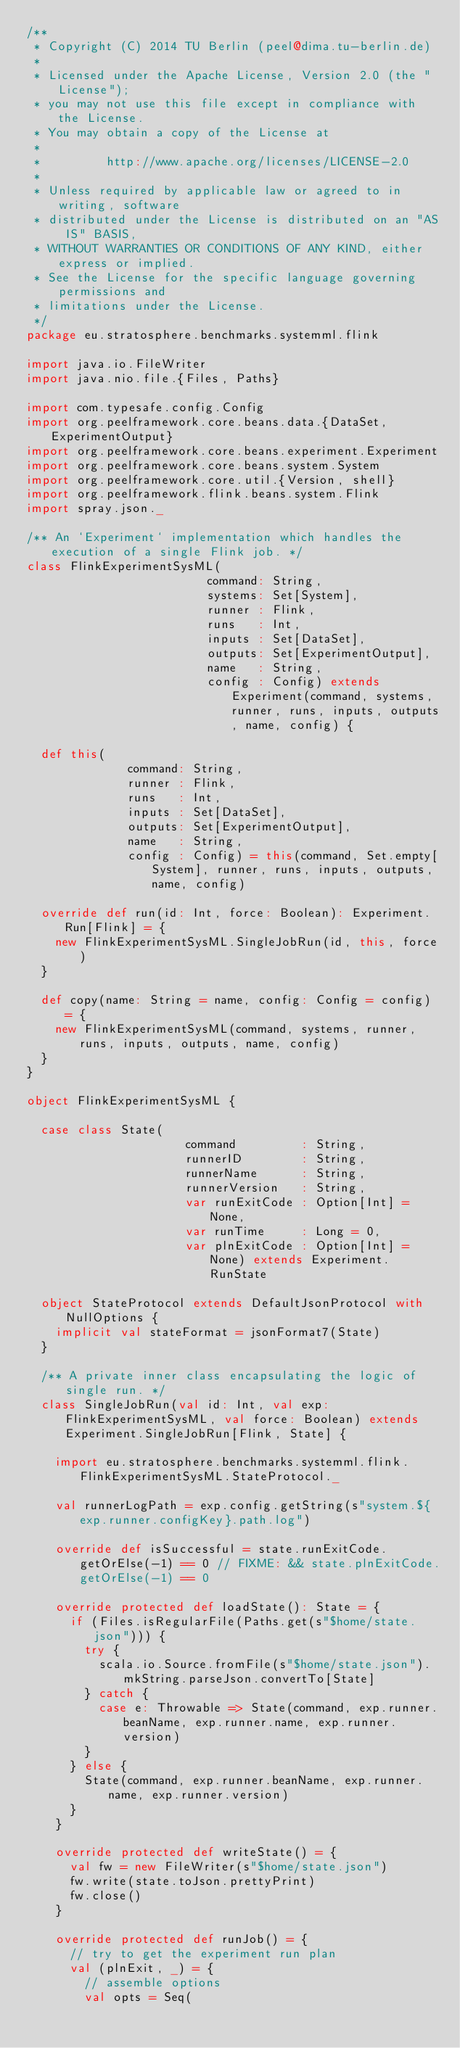<code> <loc_0><loc_0><loc_500><loc_500><_Scala_>/**
 * Copyright (C) 2014 TU Berlin (peel@dima.tu-berlin.de)
 *
 * Licensed under the Apache License, Version 2.0 (the "License");
 * you may not use this file except in compliance with the License.
 * You may obtain a copy of the License at
 *
 *         http://www.apache.org/licenses/LICENSE-2.0
 *
 * Unless required by applicable law or agreed to in writing, software
 * distributed under the License is distributed on an "AS IS" BASIS,
 * WITHOUT WARRANTIES OR CONDITIONS OF ANY KIND, either express or implied.
 * See the License for the specific language governing permissions and
 * limitations under the License.
 */
package eu.stratosphere.benchmarks.systemml.flink

import java.io.FileWriter
import java.nio.file.{Files, Paths}

import com.typesafe.config.Config
import org.peelframework.core.beans.data.{DataSet, ExperimentOutput}
import org.peelframework.core.beans.experiment.Experiment
import org.peelframework.core.beans.system.System
import org.peelframework.core.util.{Version, shell}
import org.peelframework.flink.beans.system.Flink
import spray.json._

/** An `Experiment` implementation which handles the execution of a single Flink job. */
class FlinkExperimentSysML(
                         command: String,
                         systems: Set[System],
                         runner : Flink,
                         runs   : Int,
                         inputs : Set[DataSet],
                         outputs: Set[ExperimentOutput],
                         name   : String,
                         config : Config) extends Experiment(command, systems, runner, runs, inputs, outputs, name, config) {

  def this(
              command: String,
              runner : Flink,
              runs   : Int,
              inputs : Set[DataSet],
              outputs: Set[ExperimentOutput],
              name   : String,
              config : Config) = this(command, Set.empty[System], runner, runs, inputs, outputs, name, config)

  override def run(id: Int, force: Boolean): Experiment.Run[Flink] = {
    new FlinkExperimentSysML.SingleJobRun(id, this, force)
  }

  def copy(name: String = name, config: Config = config) = {
    new FlinkExperimentSysML(command, systems, runner, runs, inputs, outputs, name, config)
  }
}

object FlinkExperimentSysML {

  case class State(
                      command         : String,
                      runnerID        : String,
                      runnerName      : String,
                      runnerVersion   : String,
                      var runExitCode : Option[Int] = None,
                      var runTime     : Long = 0,
                      var plnExitCode : Option[Int] = None) extends Experiment.RunState

  object StateProtocol extends DefaultJsonProtocol with NullOptions {
    implicit val stateFormat = jsonFormat7(State)
  }

  /** A private inner class encapsulating the logic of single run. */
  class SingleJobRun(val id: Int, val exp: FlinkExperimentSysML, val force: Boolean) extends Experiment.SingleJobRun[Flink, State] {

    import eu.stratosphere.benchmarks.systemml.flink.FlinkExperimentSysML.StateProtocol._

    val runnerLogPath = exp.config.getString(s"system.${exp.runner.configKey}.path.log")

    override def isSuccessful = state.runExitCode.getOrElse(-1) == 0 // FIXME: && state.plnExitCode.getOrElse(-1) == 0

    override protected def loadState(): State = {
      if (Files.isRegularFile(Paths.get(s"$home/state.json"))) {
        try {
          scala.io.Source.fromFile(s"$home/state.json").mkString.parseJson.convertTo[State]
        } catch {
          case e: Throwable => State(command, exp.runner.beanName, exp.runner.name, exp.runner.version)
        }
      } else {
        State(command, exp.runner.beanName, exp.runner.name, exp.runner.version)
      }
    }

    override protected def writeState() = {
      val fw = new FileWriter(s"$home/state.json")
      fw.write(state.toJson.prettyPrint)
      fw.close()
    }

    override protected def runJob() = {
      // try to get the experiment run plan
      val (plnExit, _) = {
        // assemble options
        val opts = Seq(</code> 